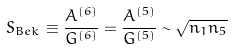<formula> <loc_0><loc_0><loc_500><loc_500>S _ { B e k } \equiv \frac { A ^ { ( 6 ) } } { G ^ { ( 6 ) } } = \frac { A ^ { ( 5 ) } } { G ^ { ( 5 ) } } \sim \sqrt { n _ { 1 } n _ { 5 } }</formula> 